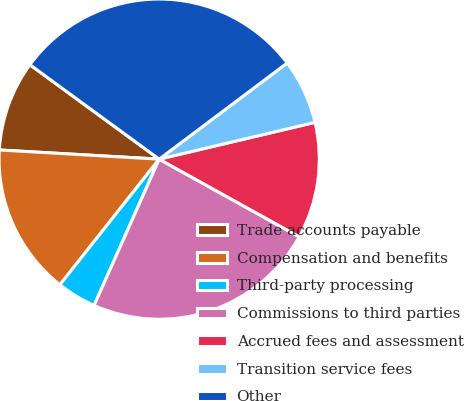Convert chart. <chart><loc_0><loc_0><loc_500><loc_500><pie_chart><fcel>Trade accounts payable<fcel>Compensation and benefits<fcel>Third-party processing<fcel>Commissions to third parties<fcel>Accrued fees and assessment<fcel>Transition service fees<fcel>Other<nl><fcel>9.13%<fcel>15.27%<fcel>3.98%<fcel>23.61%<fcel>11.75%<fcel>6.56%<fcel>29.71%<nl></chart> 